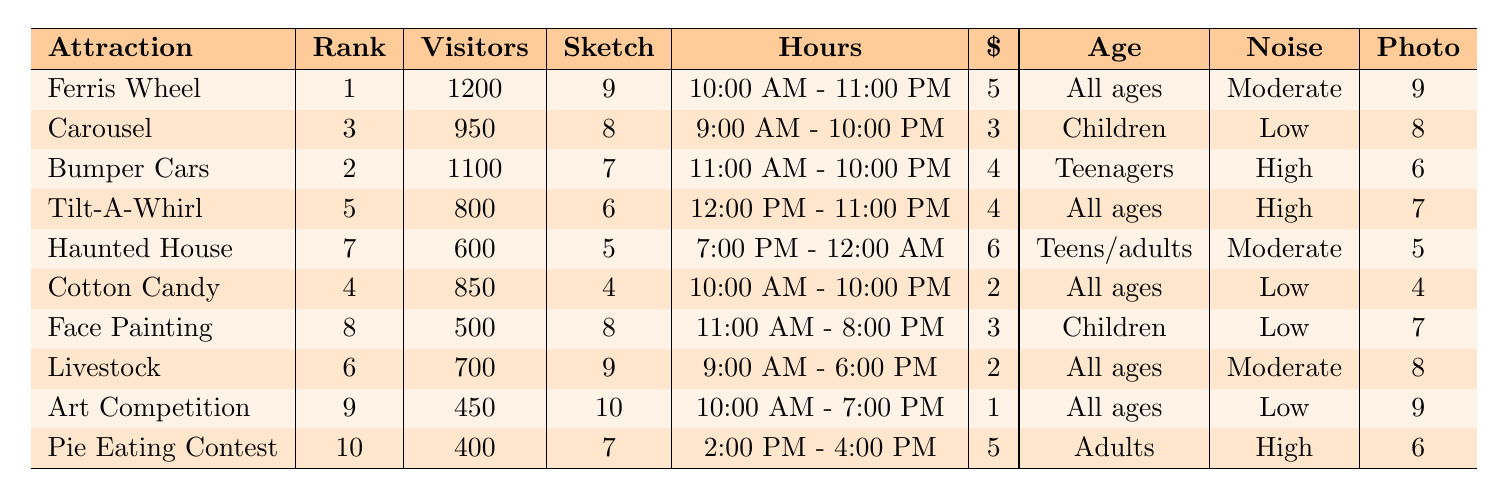What is the popularity rank of the Haunted House? The table shows that the Haunted House has a popularity rank of 7 listed in the second column.
Answer: 7 Which attraction has the highest average daily visitors? By reviewing the 'average daily visitors' column, the Ferris Wheel has the highest number with 1200 visitors.
Answer: Ferris Wheel How many ticket prices are less than $3? The ticket prices below $3 are for the Cotton Candy Stand and Livestock Exhibition, giving us a total of 2 attractions.
Answer: 2 What is the average 'sketch potential score' of all attractions? The sketch potential scores are 9, 8, 7, 6, 5, 4, 8, 9, 10, 7. Adding them gives 9+8+7+6+5+4+8+9+10+7 = 81, and dividing by 10 (total attractions) gives 8.1.
Answer: 8.1 Is Face Painting Booth suitable for older adults? The age group appeal for Face Painting Booth is 'Children,' thus it is not suitable for older adults.
Answer: No Which attraction is available the longest during the day? The Ferris Wheel is open from 10:00 AM to 11:00 PM for 13 hours, more than any other attraction; making it the longest available attraction.
Answer: Ferris Wheel What is the 'photo opportunities' score for the Carousel? The 'photo opportunities' score for the Carousel listed in the table is 8.
Answer: 8 How many attractions cater to 'all ages'? The attractions for 'all ages' are Ferris Wheel, Tilt-A-Whirl, Cotton Candy Stand, Livestock Exhibition, Art Competition. Counting these gives 5 attractions.
Answer: 5 What is the difference in average daily visitors between Bumper Cars and Haunted House? Bumper Cars have 1100 average daily visitors, while Haunted House has 600. The difference is 1100 - 600 = 500.
Answer: 500 Which attractions are open on weekends? Since all attractions are open between 10 AM to 11 PM on weekends based on usual fair scheduling, most are open, with exceptions for the Pie Eating Contest with limited hours. Given community standards, the rest can be presumed open.
Answer: All attractions except Pie Eating Contest 